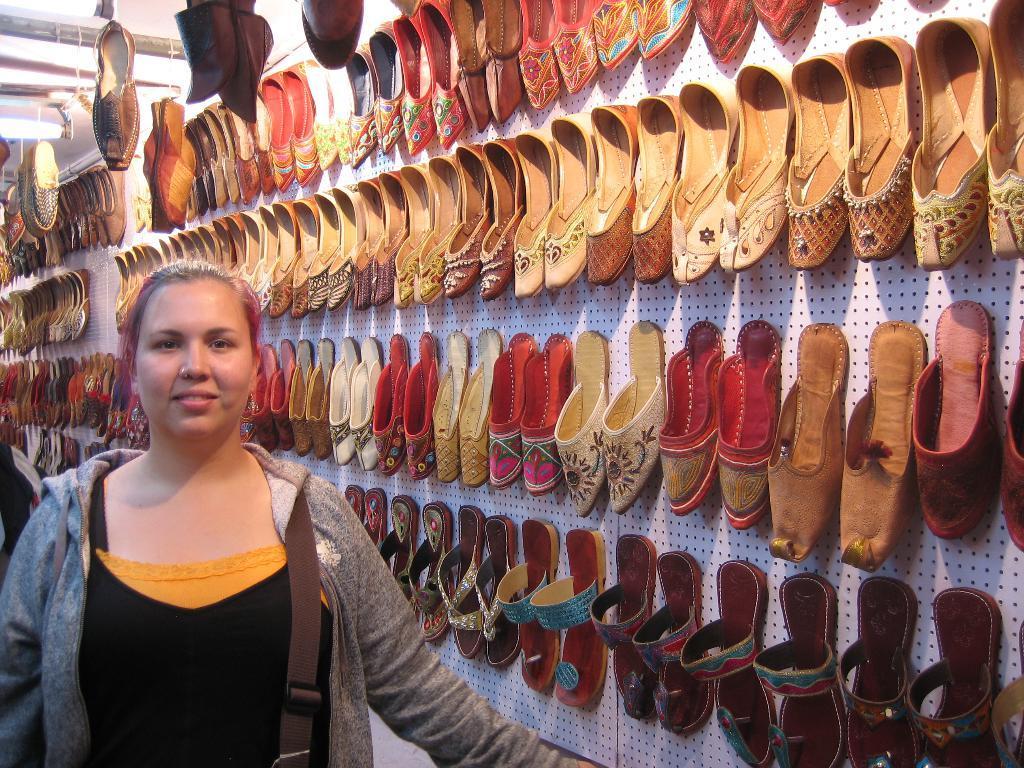Can you describe this image briefly? In this image, we can see a lady wearing a bag and in the background, there are shoes and chappals on the board. 